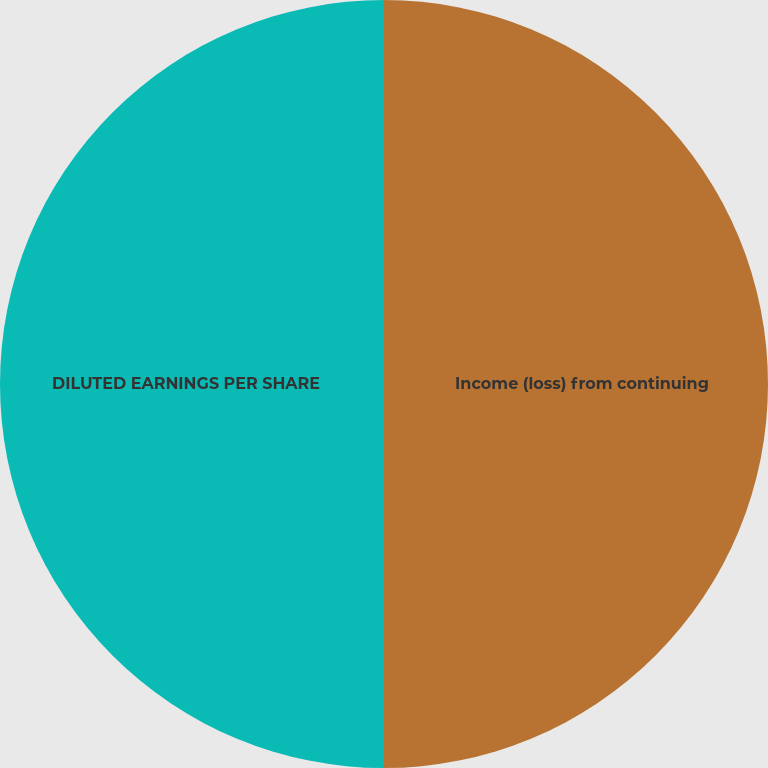Convert chart to OTSL. <chart><loc_0><loc_0><loc_500><loc_500><pie_chart><fcel>Income (loss) from continuing<fcel>DILUTED EARNINGS PER SHARE<nl><fcel>50.0%<fcel>50.0%<nl></chart> 